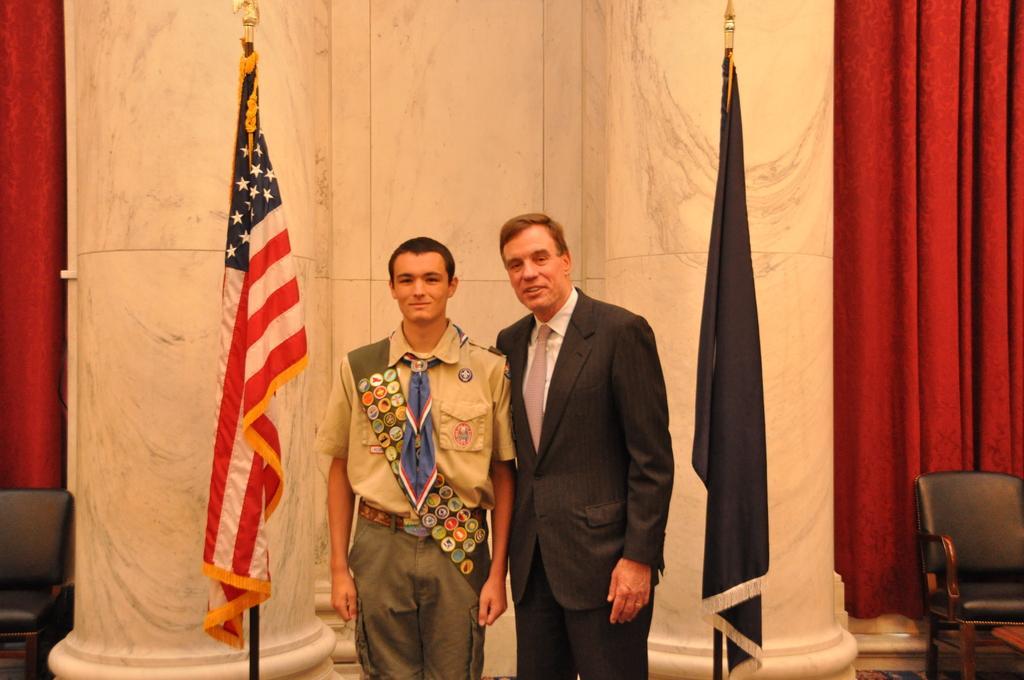Please provide a concise description of this image. In this Image I see 2 men, in which this man is wearing a uniform and this man is wearing a suit and I see that both of them are smiling. In the background I see the flags, curtain and the chairs. 